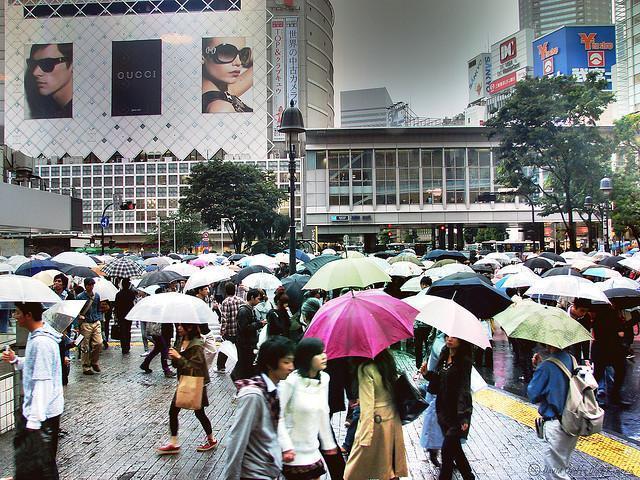How many umbrellas are pink?
Give a very brief answer. 1. How many backpacks are there?
Give a very brief answer. 1. How many people are in the photo?
Give a very brief answer. 8. How many umbrellas can be seen?
Give a very brief answer. 6. How many skis is the boy holding?
Give a very brief answer. 0. 